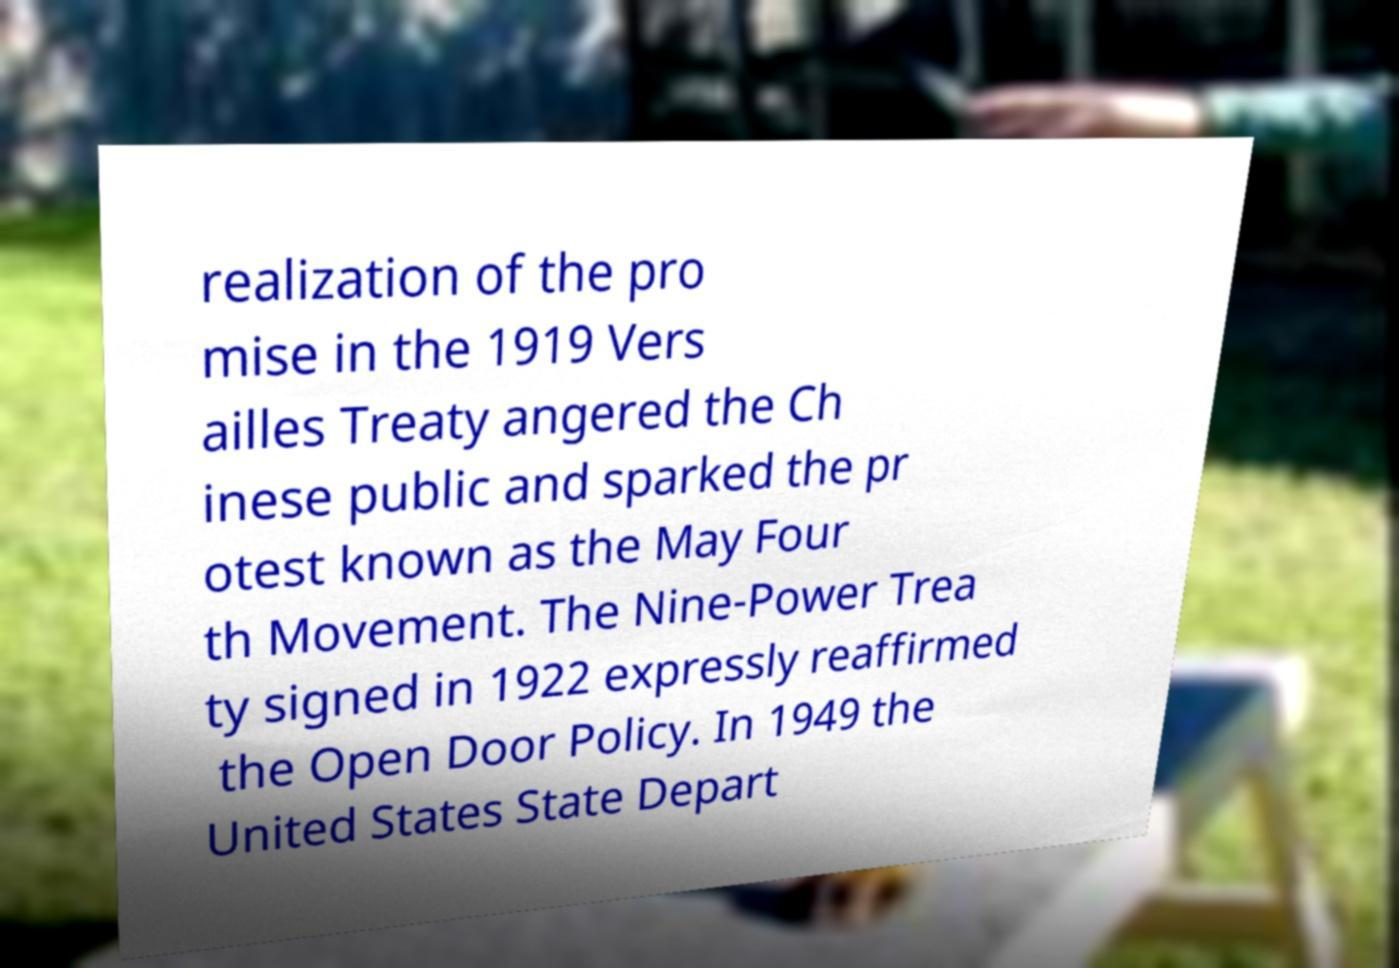Please identify and transcribe the text found in this image. realization of the pro mise in the 1919 Vers ailles Treaty angered the Ch inese public and sparked the pr otest known as the May Four th Movement. The Nine-Power Trea ty signed in 1922 expressly reaffirmed the Open Door Policy. In 1949 the United States State Depart 